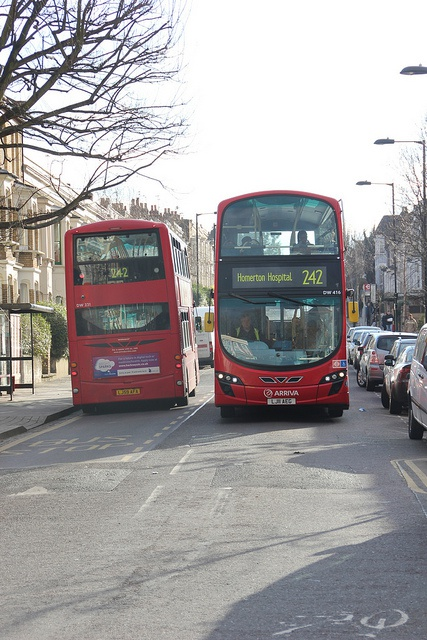Describe the objects in this image and their specific colors. I can see bus in white, gray, black, blue, and maroon tones, bus in white, gray, brown, and black tones, car in white, darkgray, gray, and black tones, car in white, gray, darkgray, and black tones, and car in white, black, darkgray, lightgray, and gray tones in this image. 